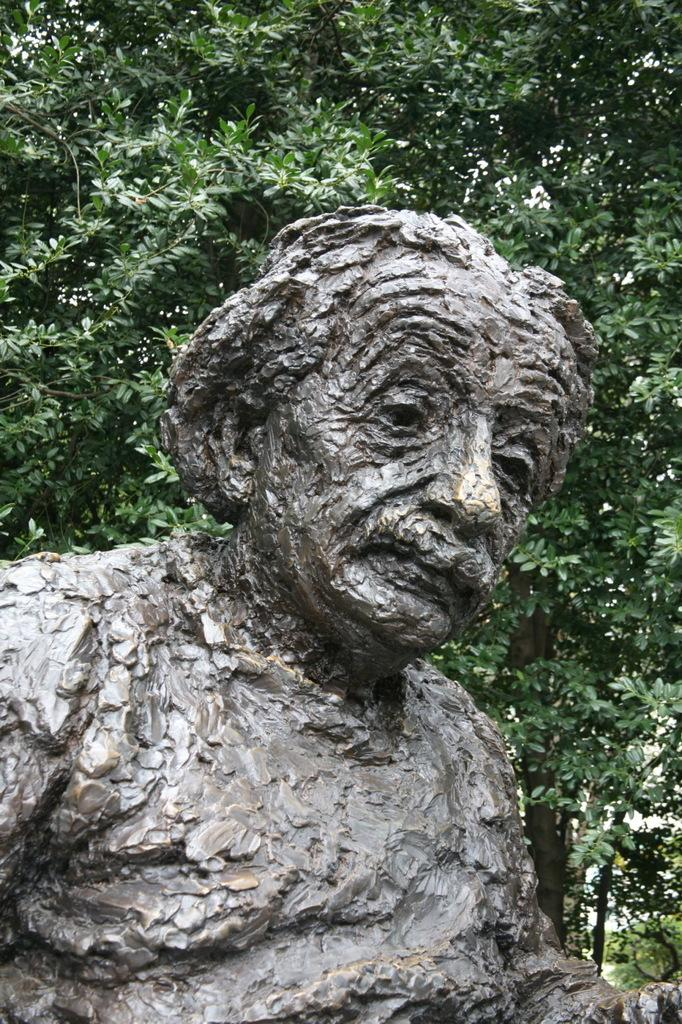What is the main subject of the image? There is a statue of a man in the image. What can be seen in the background of the image? There are trees visible in the background of the image. What position does the man take in the image? The man is a statue, so he is not in a position that can be described in terms of movement or action. Is there a chair next to the statue in the image? There is no mention of a chair in the image, so we cannot confirm its presence. 